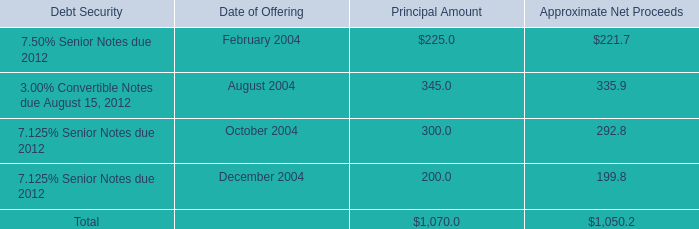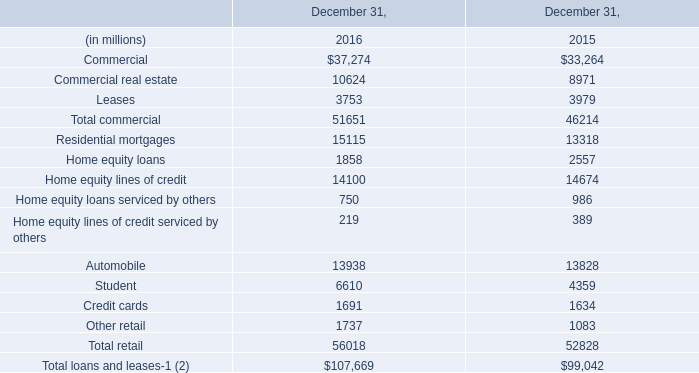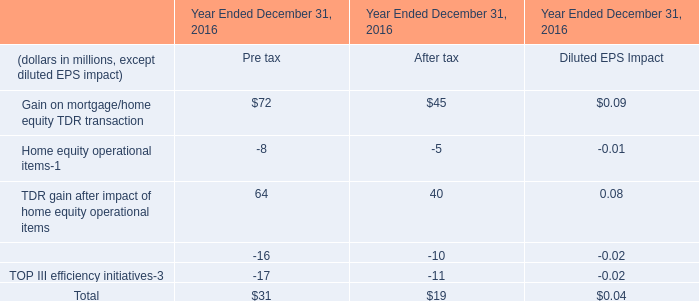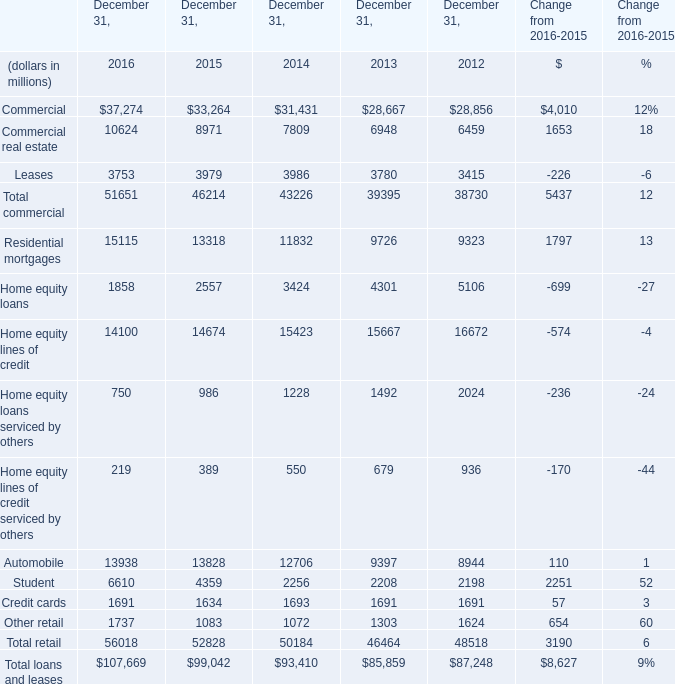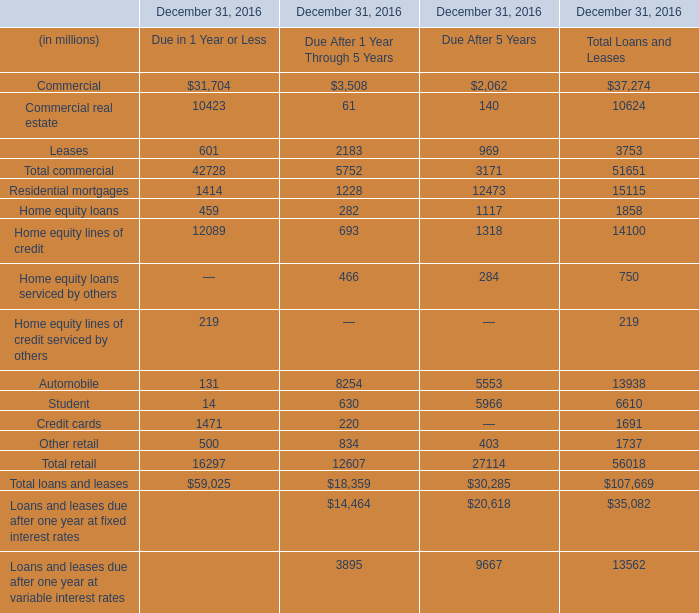In which year is Commercial Due in 1 Year or Less positive? 
Answer: 2016. 